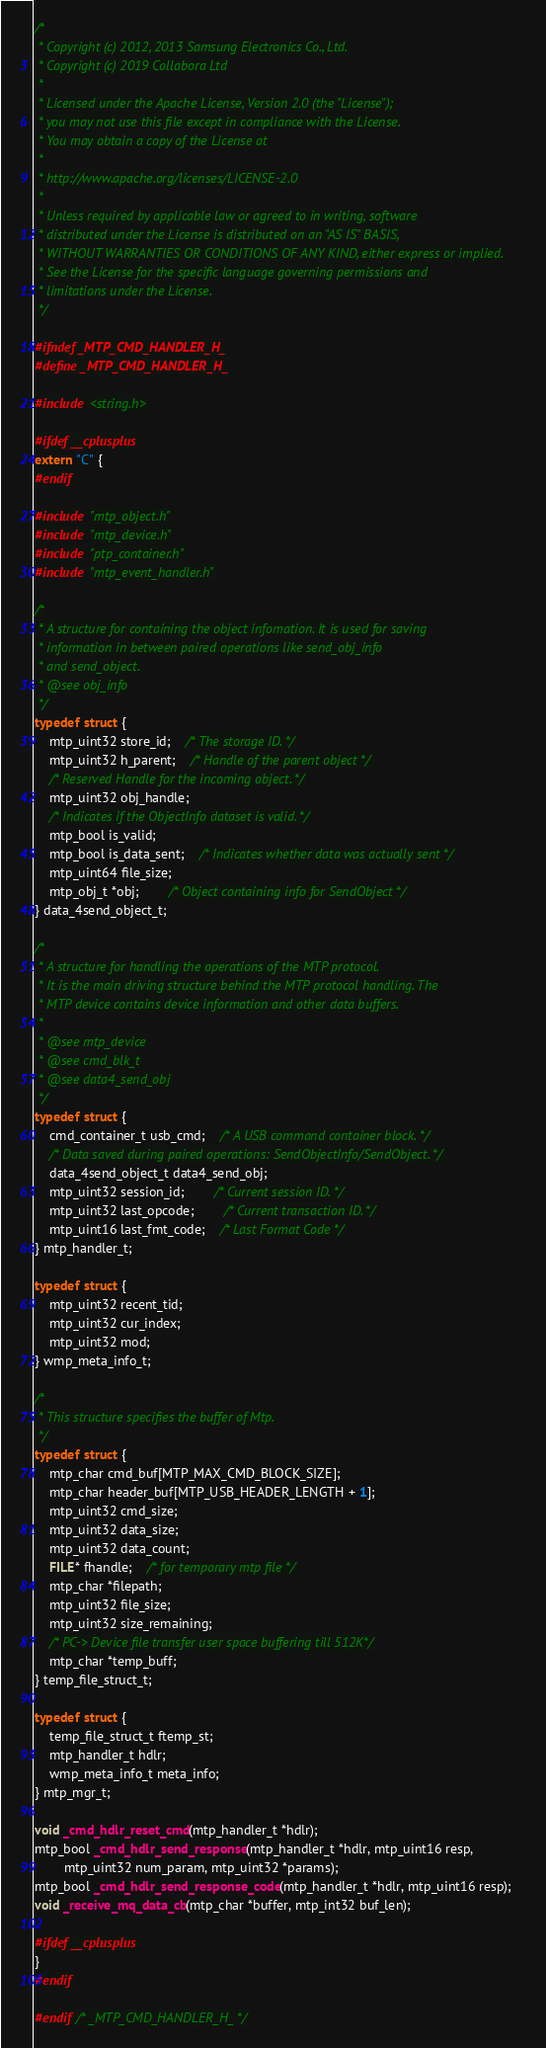Convert code to text. <code><loc_0><loc_0><loc_500><loc_500><_C_>/*
 * Copyright (c) 2012, 2013 Samsung Electronics Co., Ltd.
 * Copyright (c) 2019 Collabora Ltd
 *
 * Licensed under the Apache License, Version 2.0 (the "License");
 * you may not use this file except in compliance with the License.
 * You may obtain a copy of the License at
 *
 * http://www.apache.org/licenses/LICENSE-2.0
 *
 * Unless required by applicable law or agreed to in writing, software
 * distributed under the License is distributed on an "AS IS" BASIS,
 * WITHOUT WARRANTIES OR CONDITIONS OF ANY KIND, either express or implied.
 * See the License for the specific language governing permissions and
 * limitations under the License.
 */

#ifndef _MTP_CMD_HANDLER_H_
#define _MTP_CMD_HANDLER_H_

#include <string.h>

#ifdef __cplusplus
extern "C" {
#endif

#include "mtp_object.h"
#include "mtp_device.h"
#include "ptp_container.h"
#include "mtp_event_handler.h"

/*
 * A structure for containing the object infomation. It is used for saving
 * information in between paired operations like send_obj_info
 * and send_object.
 * @see obj_info
 */
typedef struct {
	mtp_uint32 store_id;	/* The storage ID. */
	mtp_uint32 h_parent;	/* Handle of the parent object */
	/* Reserved Handle for the incoming object. */
	mtp_uint32 obj_handle;
	/* Indicates if the ObjectInfo dataset is valid. */
	mtp_bool is_valid;
	mtp_bool is_data_sent;	/* Indicates whether data was actually sent */
	mtp_uint64 file_size;
	mtp_obj_t *obj;		/* Object containing info for SendObject */
} data_4send_object_t;

/*
 * A structure for handling the operations of the MTP protocol.
 * It is the main driving structure behind the MTP protocol handling. The
 * MTP device contains device information and other data buffers.
 *
 * @see mtp_device
 * @see cmd_blk_t
 * @see data4_send_obj
 */
typedef struct {
	cmd_container_t usb_cmd;	/* A USB command container block. */
	/* Data saved during paired operations: SendObjectInfo/SendObject. */
	data_4send_object_t data4_send_obj;
	mtp_uint32 session_id;		/* Current session ID. */
	mtp_uint32 last_opcode;		/* Current transaction ID. */
	mtp_uint16 last_fmt_code;	/* Last Format Code */
} mtp_handler_t;

typedef struct {
	mtp_uint32 recent_tid;
	mtp_uint32 cur_index;
	mtp_uint32 mod;
} wmp_meta_info_t;

/*
 * This structure specifies the buffer of Mtp.
 */
typedef struct {
	mtp_char cmd_buf[MTP_MAX_CMD_BLOCK_SIZE];
	mtp_char header_buf[MTP_USB_HEADER_LENGTH + 1];
	mtp_uint32 cmd_size;
	mtp_uint32 data_size;
	mtp_uint32 data_count;
	FILE* fhandle;	/* for temporary mtp file */
	mtp_char *filepath;
	mtp_uint32 file_size;
	mtp_uint32 size_remaining;
	/* PC-> Device file transfer user space buffering till 512K*/
	mtp_char *temp_buff;
} temp_file_struct_t;

typedef struct {
	temp_file_struct_t ftemp_st;
	mtp_handler_t hdlr;
	wmp_meta_info_t meta_info;
} mtp_mgr_t;

void _cmd_hdlr_reset_cmd(mtp_handler_t *hdlr);
mtp_bool _cmd_hdlr_send_response(mtp_handler_t *hdlr, mtp_uint16 resp,
		mtp_uint32 num_param, mtp_uint32 *params);
mtp_bool _cmd_hdlr_send_response_code(mtp_handler_t *hdlr, mtp_uint16 resp);
void _receive_mq_data_cb(mtp_char *buffer, mtp_int32 buf_len);

#ifdef __cplusplus
}
#endif

#endif /* _MTP_CMD_HANDLER_H_ */
</code> 